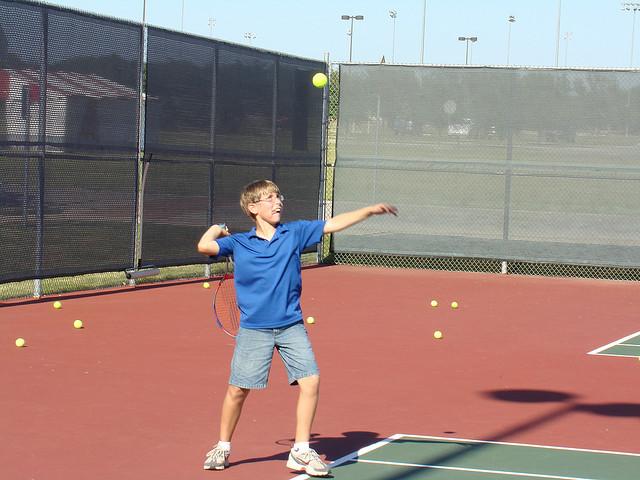What color is the court?
Give a very brief answer. Red. At what is this boy staring at?
Quick response, please. Ball. Is the kid throwing a ball?
Write a very short answer. No. 